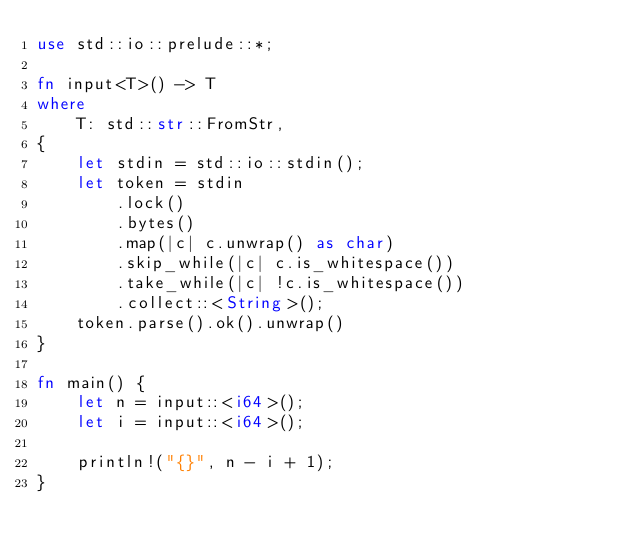Convert code to text. <code><loc_0><loc_0><loc_500><loc_500><_Rust_>use std::io::prelude::*;

fn input<T>() -> T
where
    T: std::str::FromStr,
{
    let stdin = std::io::stdin();
    let token = stdin
        .lock()
        .bytes()
        .map(|c| c.unwrap() as char)
        .skip_while(|c| c.is_whitespace())
        .take_while(|c| !c.is_whitespace())
        .collect::<String>();
    token.parse().ok().unwrap()
}

fn main() {
    let n = input::<i64>();
    let i = input::<i64>();

    println!("{}", n - i + 1);
}
</code> 